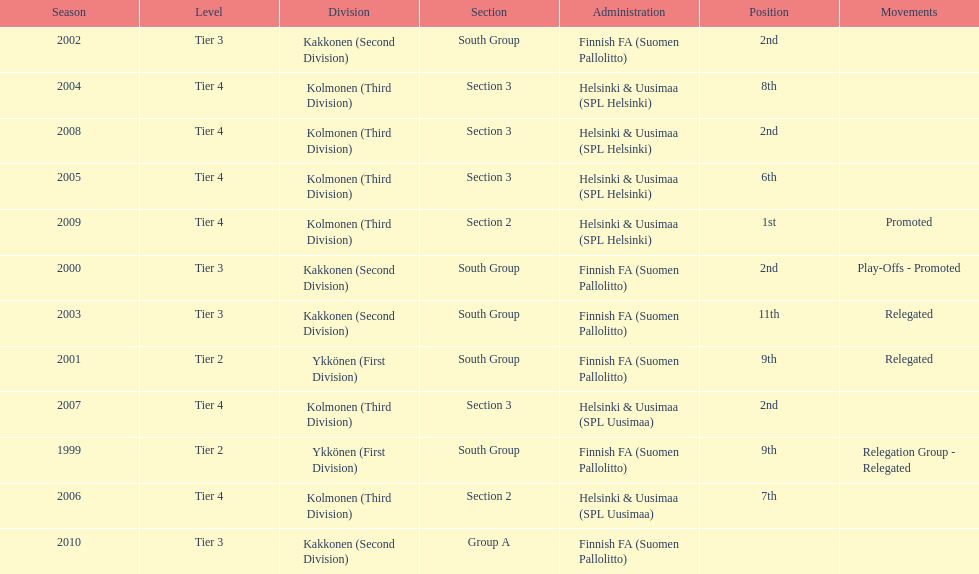How many consecutive times did they play in tier 4? 6. 